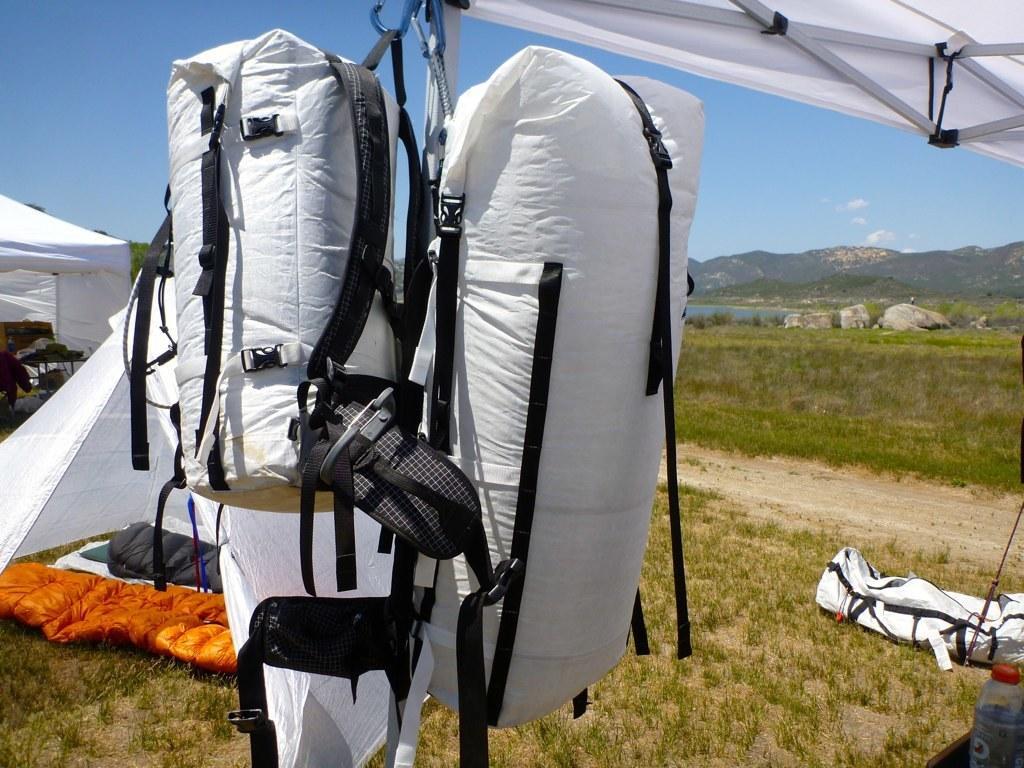How would you summarize this image in a sentence or two? we observe trekking equipment in this picture ,there are two white bags hanged to the roof , there is also a orange color tent kept on the floor. In the background we observe sea and mountains. 